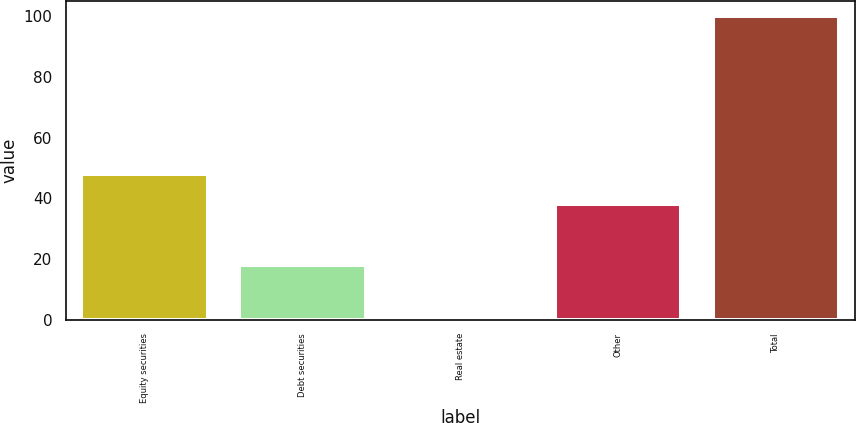Convert chart. <chart><loc_0><loc_0><loc_500><loc_500><bar_chart><fcel>Equity securities<fcel>Debt securities<fcel>Real estate<fcel>Other<fcel>Total<nl><fcel>48.08<fcel>18.1<fcel>1.2<fcel>38.2<fcel>100<nl></chart> 